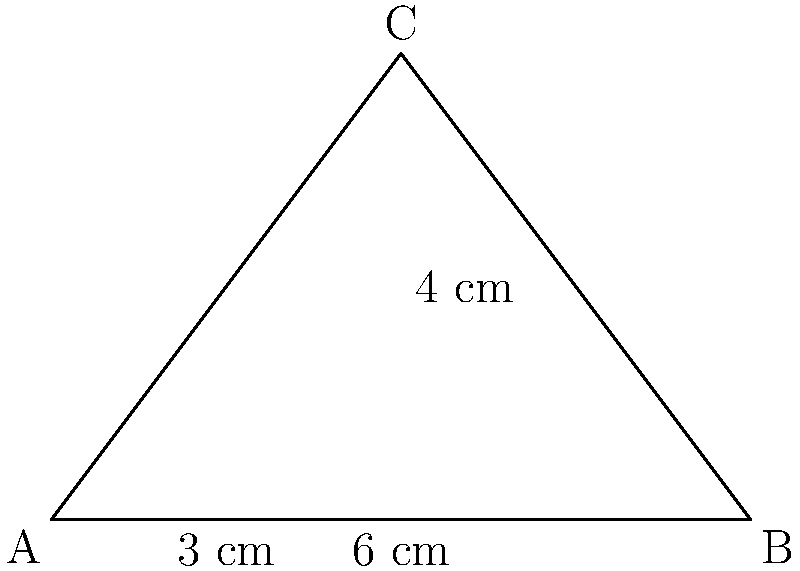In Terni's city center, there's a triangular park shaped like a right triangle. The base of the park measures 6 cm, and its height is 4 cm. If the city council wants to install a fence around the perimeter of the park, how many centimeters of fencing material will they need? To find the perimeter of the triangular park, we need to calculate the lengths of all three sides and add them together. We're given the base and height, but we need to find the length of the hypotenuse.

1. We know the base (b) = 6 cm and height (h) = 4 cm.

2. To find the hypotenuse (c), we can use the Pythagorean theorem: $a^2 + b^2 = c^2$

3. Substituting the values:
   $3^2 + 4^2 = c^2$
   $9 + 16 = c^2$
   $25 = c^2$

4. Taking the square root of both sides:
   $c = \sqrt{25} = 5$ cm

5. Now we have all three sides:
   Base = 6 cm
   Height = 4 cm
   Hypotenuse = 5 cm

6. The perimeter is the sum of all sides:
   Perimeter = 6 + 4 + 5 = 15 cm

Therefore, the city council will need 15 cm of fencing material to enclose the triangular park.
Answer: 15 cm 